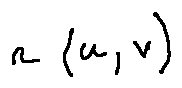<formula> <loc_0><loc_0><loc_500><loc_500>r ( u , v )</formula> 